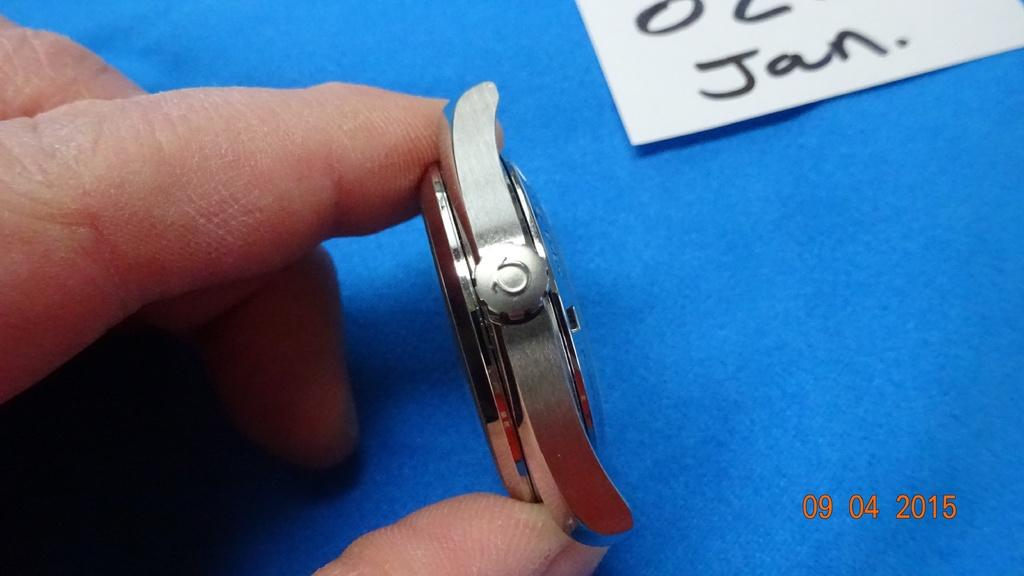<image>
Present a compact description of the photo's key features. A person is holding a watch face sideways and a card on the table has the abbreviation for January on it. 